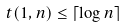Convert formula to latex. <formula><loc_0><loc_0><loc_500><loc_500>t ( 1 , n ) \leq \lceil \log n \rceil</formula> 